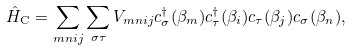Convert formula to latex. <formula><loc_0><loc_0><loc_500><loc_500>\hat { H } _ { \text {C} } = \sum _ { m n i j } \sum _ { \sigma \tau } { V } _ { m n i j } c _ { \sigma } ^ { \dagger } ( \beta _ { m } ) c _ { \tau } ^ { \dagger } ( \beta _ { i } ) c _ { \tau } ( \beta _ { j } ) c _ { \sigma } ( \beta _ { n } ) ,</formula> 